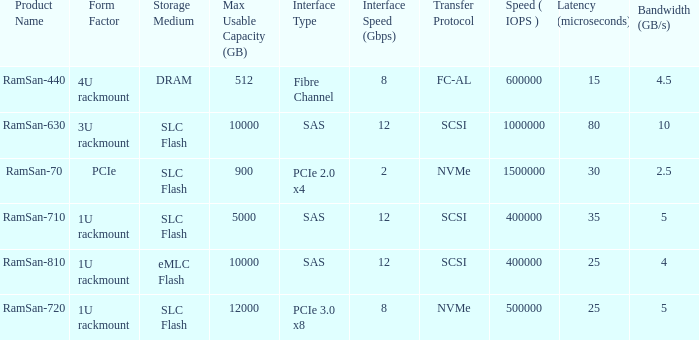What is the shape distortion for the range frequency of 10? 3U rackmount. 